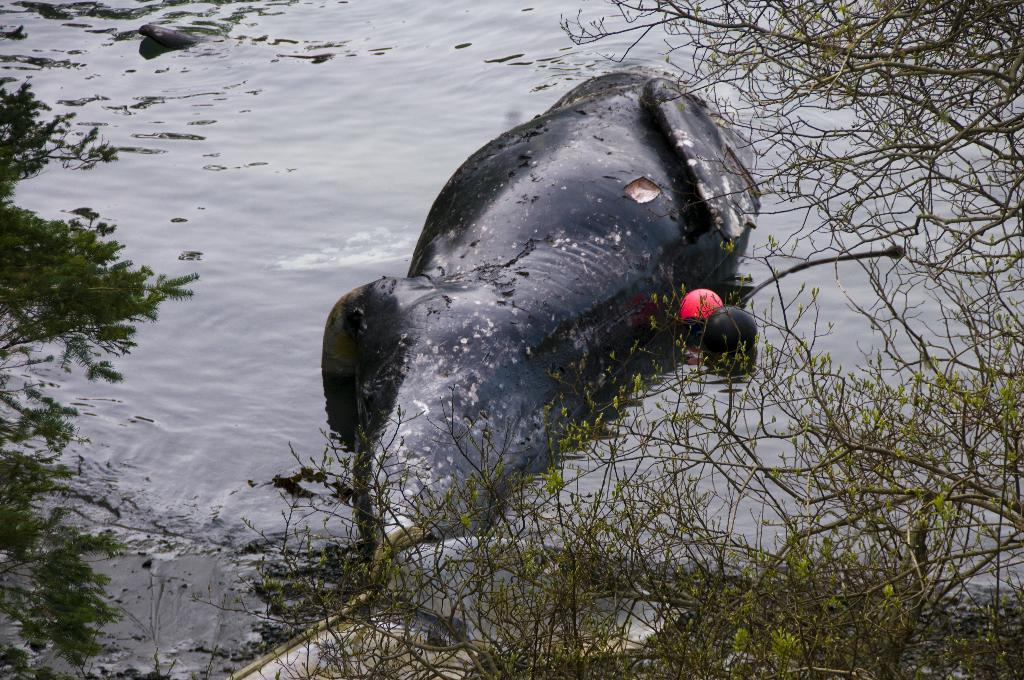What is the animal doing in the image? The animal is swimming in the water in the image. What type of vegetation can be seen in the image? Trees are visible at the bottom of the image. What structure is present in the image? There is a wall in the image. What type of copper is being used to trick the animal in the image? There is no copper or trickery present in the image; it features an animal swimming in the water with trees and a wall visible. 